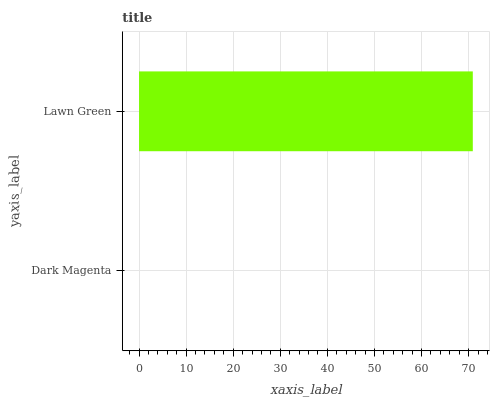Is Dark Magenta the minimum?
Answer yes or no. Yes. Is Lawn Green the maximum?
Answer yes or no. Yes. Is Lawn Green the minimum?
Answer yes or no. No. Is Lawn Green greater than Dark Magenta?
Answer yes or no. Yes. Is Dark Magenta less than Lawn Green?
Answer yes or no. Yes. Is Dark Magenta greater than Lawn Green?
Answer yes or no. No. Is Lawn Green less than Dark Magenta?
Answer yes or no. No. Is Lawn Green the high median?
Answer yes or no. Yes. Is Dark Magenta the low median?
Answer yes or no. Yes. Is Dark Magenta the high median?
Answer yes or no. No. Is Lawn Green the low median?
Answer yes or no. No. 